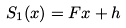Convert formula to latex. <formula><loc_0><loc_0><loc_500><loc_500>S _ { 1 } ( x ) = F x + h</formula> 